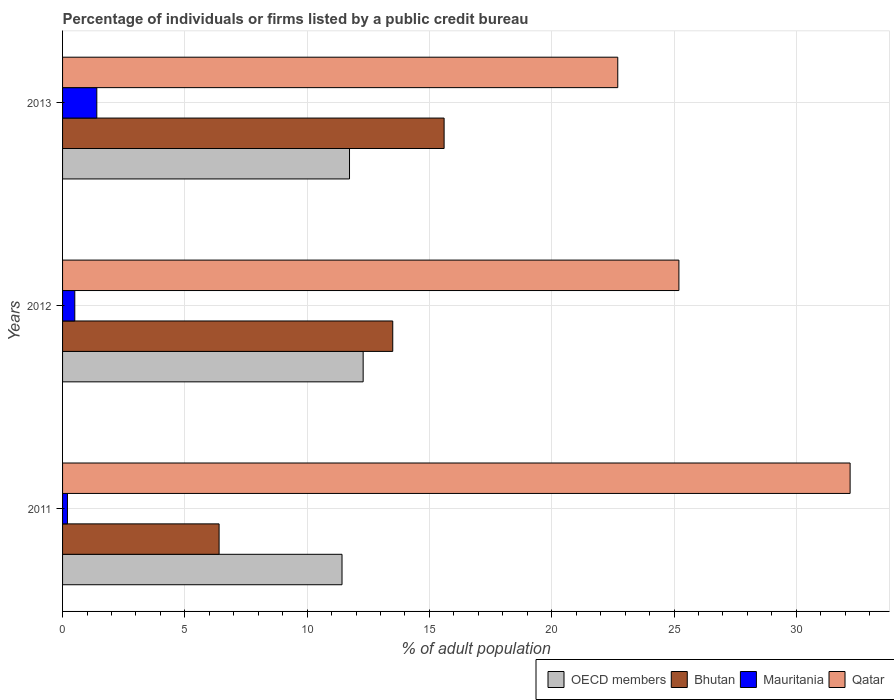Are the number of bars on each tick of the Y-axis equal?
Provide a succinct answer. Yes. How many bars are there on the 3rd tick from the top?
Offer a very short reply. 4. What is the label of the 1st group of bars from the top?
Provide a short and direct response. 2013. What is the percentage of population listed by a public credit bureau in OECD members in 2013?
Your answer should be very brief. 11.73. Across all years, what is the maximum percentage of population listed by a public credit bureau in Bhutan?
Offer a terse response. 15.6. Across all years, what is the minimum percentage of population listed by a public credit bureau in Qatar?
Your answer should be compact. 22.7. In which year was the percentage of population listed by a public credit bureau in Mauritania maximum?
Keep it short and to the point. 2013. In which year was the percentage of population listed by a public credit bureau in OECD members minimum?
Provide a succinct answer. 2011. What is the total percentage of population listed by a public credit bureau in Bhutan in the graph?
Provide a short and direct response. 35.5. What is the average percentage of population listed by a public credit bureau in Qatar per year?
Offer a very short reply. 26.7. In the year 2012, what is the difference between the percentage of population listed by a public credit bureau in Bhutan and percentage of population listed by a public credit bureau in Mauritania?
Ensure brevity in your answer.  13. In how many years, is the percentage of population listed by a public credit bureau in Mauritania greater than 2 %?
Your response must be concise. 0. What is the ratio of the percentage of population listed by a public credit bureau in Bhutan in 2011 to that in 2012?
Make the answer very short. 0.47. Is the difference between the percentage of population listed by a public credit bureau in Bhutan in 2011 and 2012 greater than the difference between the percentage of population listed by a public credit bureau in Mauritania in 2011 and 2012?
Your answer should be very brief. No. What is the difference between the highest and the second highest percentage of population listed by a public credit bureau in Bhutan?
Make the answer very short. 2.1. What is the difference between the highest and the lowest percentage of population listed by a public credit bureau in Qatar?
Provide a succinct answer. 9.5. In how many years, is the percentage of population listed by a public credit bureau in OECD members greater than the average percentage of population listed by a public credit bureau in OECD members taken over all years?
Your answer should be compact. 1. Is the sum of the percentage of population listed by a public credit bureau in OECD members in 2012 and 2013 greater than the maximum percentage of population listed by a public credit bureau in Mauritania across all years?
Your response must be concise. Yes. Is it the case that in every year, the sum of the percentage of population listed by a public credit bureau in Bhutan and percentage of population listed by a public credit bureau in Mauritania is greater than the sum of percentage of population listed by a public credit bureau in Qatar and percentage of population listed by a public credit bureau in OECD members?
Give a very brief answer. Yes. What does the 3rd bar from the top in 2012 represents?
Keep it short and to the point. Bhutan. What does the 1st bar from the bottom in 2012 represents?
Make the answer very short. OECD members. Is it the case that in every year, the sum of the percentage of population listed by a public credit bureau in Qatar and percentage of population listed by a public credit bureau in OECD members is greater than the percentage of population listed by a public credit bureau in Bhutan?
Your answer should be compact. Yes. Are all the bars in the graph horizontal?
Ensure brevity in your answer.  Yes. Are the values on the major ticks of X-axis written in scientific E-notation?
Keep it short and to the point. No. Does the graph contain grids?
Offer a terse response. Yes. How many legend labels are there?
Ensure brevity in your answer.  4. What is the title of the graph?
Your response must be concise. Percentage of individuals or firms listed by a public credit bureau. What is the label or title of the X-axis?
Offer a very short reply. % of adult population. What is the % of adult population of OECD members in 2011?
Your response must be concise. 11.43. What is the % of adult population in Bhutan in 2011?
Offer a terse response. 6.4. What is the % of adult population in Mauritania in 2011?
Keep it short and to the point. 0.2. What is the % of adult population in Qatar in 2011?
Give a very brief answer. 32.2. What is the % of adult population of OECD members in 2012?
Your answer should be very brief. 12.29. What is the % of adult population in Qatar in 2012?
Your response must be concise. 25.2. What is the % of adult population in OECD members in 2013?
Offer a terse response. 11.73. What is the % of adult population of Mauritania in 2013?
Provide a short and direct response. 1.4. What is the % of adult population of Qatar in 2013?
Your answer should be very brief. 22.7. Across all years, what is the maximum % of adult population of OECD members?
Your answer should be compact. 12.29. Across all years, what is the maximum % of adult population in Qatar?
Make the answer very short. 32.2. Across all years, what is the minimum % of adult population of OECD members?
Your response must be concise. 11.43. Across all years, what is the minimum % of adult population of Mauritania?
Make the answer very short. 0.2. Across all years, what is the minimum % of adult population in Qatar?
Your answer should be very brief. 22.7. What is the total % of adult population in OECD members in the graph?
Keep it short and to the point. 35.45. What is the total % of adult population in Bhutan in the graph?
Your answer should be compact. 35.5. What is the total % of adult population in Qatar in the graph?
Your answer should be compact. 80.1. What is the difference between the % of adult population in OECD members in 2011 and that in 2012?
Ensure brevity in your answer.  -0.86. What is the difference between the % of adult population in Qatar in 2011 and that in 2012?
Your answer should be very brief. 7. What is the difference between the % of adult population of OECD members in 2011 and that in 2013?
Your answer should be compact. -0.31. What is the difference between the % of adult population in Bhutan in 2011 and that in 2013?
Offer a very short reply. -9.2. What is the difference between the % of adult population of Qatar in 2011 and that in 2013?
Provide a short and direct response. 9.5. What is the difference between the % of adult population in OECD members in 2012 and that in 2013?
Your response must be concise. 0.56. What is the difference between the % of adult population of Mauritania in 2012 and that in 2013?
Your response must be concise. -0.9. What is the difference between the % of adult population in OECD members in 2011 and the % of adult population in Bhutan in 2012?
Ensure brevity in your answer.  -2.07. What is the difference between the % of adult population of OECD members in 2011 and the % of adult population of Mauritania in 2012?
Provide a short and direct response. 10.93. What is the difference between the % of adult population in OECD members in 2011 and the % of adult population in Qatar in 2012?
Keep it short and to the point. -13.77. What is the difference between the % of adult population of Bhutan in 2011 and the % of adult population of Qatar in 2012?
Offer a very short reply. -18.8. What is the difference between the % of adult population of Mauritania in 2011 and the % of adult population of Qatar in 2012?
Provide a succinct answer. -25. What is the difference between the % of adult population in OECD members in 2011 and the % of adult population in Bhutan in 2013?
Offer a terse response. -4.17. What is the difference between the % of adult population of OECD members in 2011 and the % of adult population of Mauritania in 2013?
Your answer should be compact. 10.03. What is the difference between the % of adult population of OECD members in 2011 and the % of adult population of Qatar in 2013?
Make the answer very short. -11.27. What is the difference between the % of adult population in Bhutan in 2011 and the % of adult population in Qatar in 2013?
Provide a short and direct response. -16.3. What is the difference between the % of adult population in Mauritania in 2011 and the % of adult population in Qatar in 2013?
Your answer should be very brief. -22.5. What is the difference between the % of adult population in OECD members in 2012 and the % of adult population in Bhutan in 2013?
Provide a short and direct response. -3.31. What is the difference between the % of adult population in OECD members in 2012 and the % of adult population in Mauritania in 2013?
Ensure brevity in your answer.  10.89. What is the difference between the % of adult population in OECD members in 2012 and the % of adult population in Qatar in 2013?
Provide a short and direct response. -10.41. What is the difference between the % of adult population of Bhutan in 2012 and the % of adult population of Mauritania in 2013?
Give a very brief answer. 12.1. What is the difference between the % of adult population in Mauritania in 2012 and the % of adult population in Qatar in 2013?
Keep it short and to the point. -22.2. What is the average % of adult population in OECD members per year?
Provide a short and direct response. 11.82. What is the average % of adult population of Bhutan per year?
Make the answer very short. 11.83. What is the average % of adult population of Mauritania per year?
Provide a short and direct response. 0.7. What is the average % of adult population of Qatar per year?
Your response must be concise. 26.7. In the year 2011, what is the difference between the % of adult population in OECD members and % of adult population in Bhutan?
Offer a very short reply. 5.03. In the year 2011, what is the difference between the % of adult population in OECD members and % of adult population in Mauritania?
Keep it short and to the point. 11.23. In the year 2011, what is the difference between the % of adult population of OECD members and % of adult population of Qatar?
Give a very brief answer. -20.77. In the year 2011, what is the difference between the % of adult population of Bhutan and % of adult population of Mauritania?
Give a very brief answer. 6.2. In the year 2011, what is the difference between the % of adult population in Bhutan and % of adult population in Qatar?
Provide a succinct answer. -25.8. In the year 2011, what is the difference between the % of adult population of Mauritania and % of adult population of Qatar?
Your answer should be compact. -32. In the year 2012, what is the difference between the % of adult population in OECD members and % of adult population in Bhutan?
Make the answer very short. -1.21. In the year 2012, what is the difference between the % of adult population of OECD members and % of adult population of Mauritania?
Your answer should be very brief. 11.79. In the year 2012, what is the difference between the % of adult population of OECD members and % of adult population of Qatar?
Your answer should be compact. -12.91. In the year 2012, what is the difference between the % of adult population of Mauritania and % of adult population of Qatar?
Make the answer very short. -24.7. In the year 2013, what is the difference between the % of adult population in OECD members and % of adult population in Bhutan?
Your answer should be very brief. -3.87. In the year 2013, what is the difference between the % of adult population in OECD members and % of adult population in Mauritania?
Ensure brevity in your answer.  10.33. In the year 2013, what is the difference between the % of adult population in OECD members and % of adult population in Qatar?
Your response must be concise. -10.97. In the year 2013, what is the difference between the % of adult population in Bhutan and % of adult population in Mauritania?
Offer a very short reply. 14.2. In the year 2013, what is the difference between the % of adult population in Mauritania and % of adult population in Qatar?
Offer a terse response. -21.3. What is the ratio of the % of adult population of OECD members in 2011 to that in 2012?
Your response must be concise. 0.93. What is the ratio of the % of adult population in Bhutan in 2011 to that in 2012?
Your answer should be compact. 0.47. What is the ratio of the % of adult population of Qatar in 2011 to that in 2012?
Offer a terse response. 1.28. What is the ratio of the % of adult population of OECD members in 2011 to that in 2013?
Offer a very short reply. 0.97. What is the ratio of the % of adult population of Bhutan in 2011 to that in 2013?
Make the answer very short. 0.41. What is the ratio of the % of adult population in Mauritania in 2011 to that in 2013?
Ensure brevity in your answer.  0.14. What is the ratio of the % of adult population of Qatar in 2011 to that in 2013?
Keep it short and to the point. 1.42. What is the ratio of the % of adult population in OECD members in 2012 to that in 2013?
Make the answer very short. 1.05. What is the ratio of the % of adult population of Bhutan in 2012 to that in 2013?
Keep it short and to the point. 0.87. What is the ratio of the % of adult population of Mauritania in 2012 to that in 2013?
Keep it short and to the point. 0.36. What is the ratio of the % of adult population of Qatar in 2012 to that in 2013?
Your answer should be compact. 1.11. What is the difference between the highest and the second highest % of adult population in OECD members?
Your answer should be compact. 0.56. What is the difference between the highest and the second highest % of adult population in Bhutan?
Ensure brevity in your answer.  2.1. What is the difference between the highest and the second highest % of adult population in Qatar?
Offer a very short reply. 7. What is the difference between the highest and the lowest % of adult population of OECD members?
Your answer should be very brief. 0.86. What is the difference between the highest and the lowest % of adult population in Bhutan?
Your answer should be compact. 9.2. What is the difference between the highest and the lowest % of adult population in Mauritania?
Make the answer very short. 1.2. 